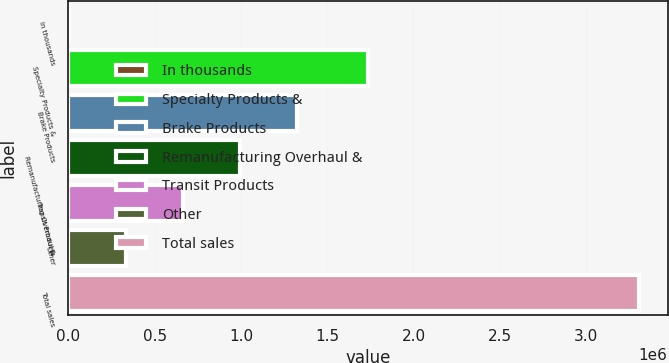Convert chart. <chart><loc_0><loc_0><loc_500><loc_500><bar_chart><fcel>In thousands<fcel>Specialty Products &<fcel>Brake Products<fcel>Remanufacturing Overhaul &<fcel>Transit Products<fcel>Other<fcel>Total sales<nl><fcel>2015<fcel>1.73388e+06<fcel>1.32441e+06<fcel>993810<fcel>663212<fcel>332613<fcel>3.308e+06<nl></chart> 